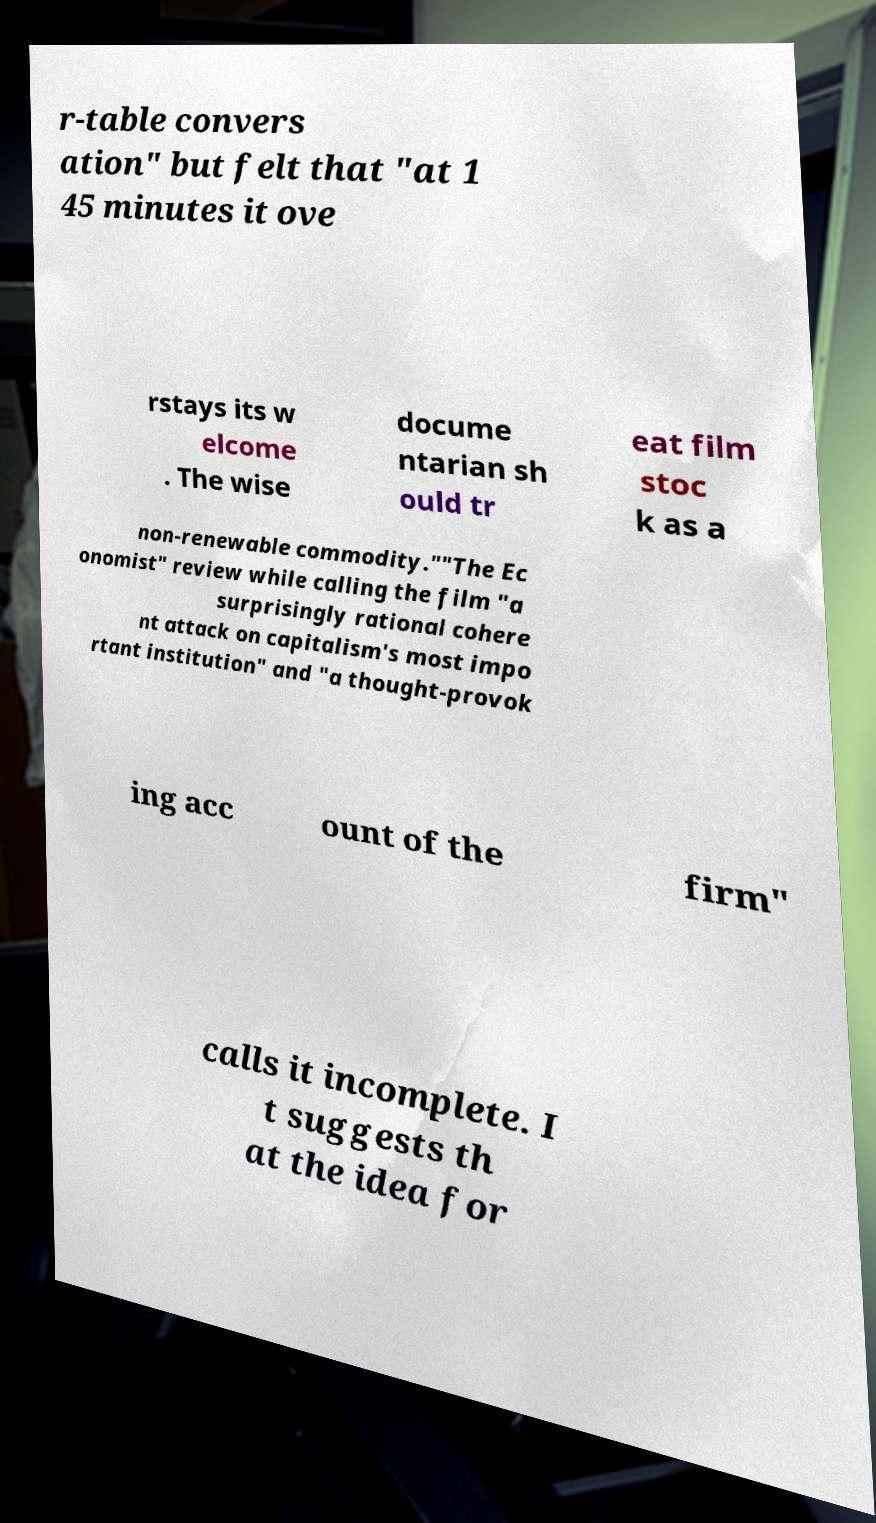I need the written content from this picture converted into text. Can you do that? r-table convers ation" but felt that "at 1 45 minutes it ove rstays its w elcome . The wise docume ntarian sh ould tr eat film stoc k as a non-renewable commodity.""The Ec onomist" review while calling the film "a surprisingly rational cohere nt attack on capitalism's most impo rtant institution" and "a thought-provok ing acc ount of the firm" calls it incomplete. I t suggests th at the idea for 